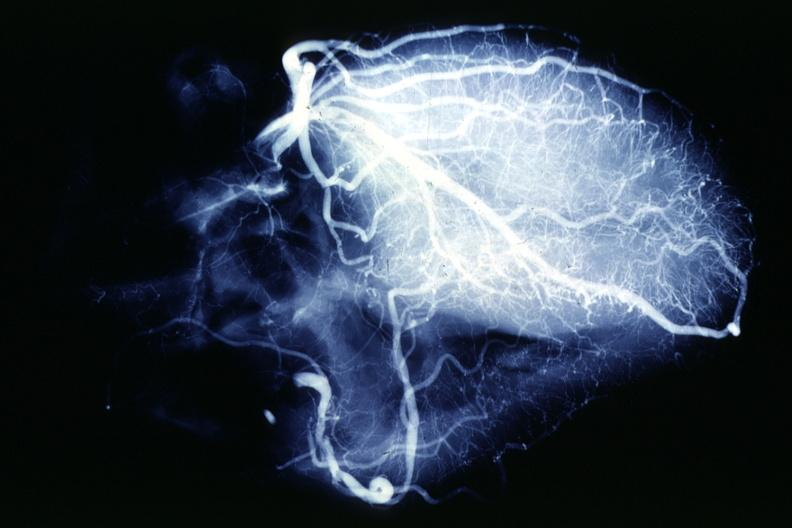s cardiovascular present?
Answer the question using a single word or phrase. Yes 